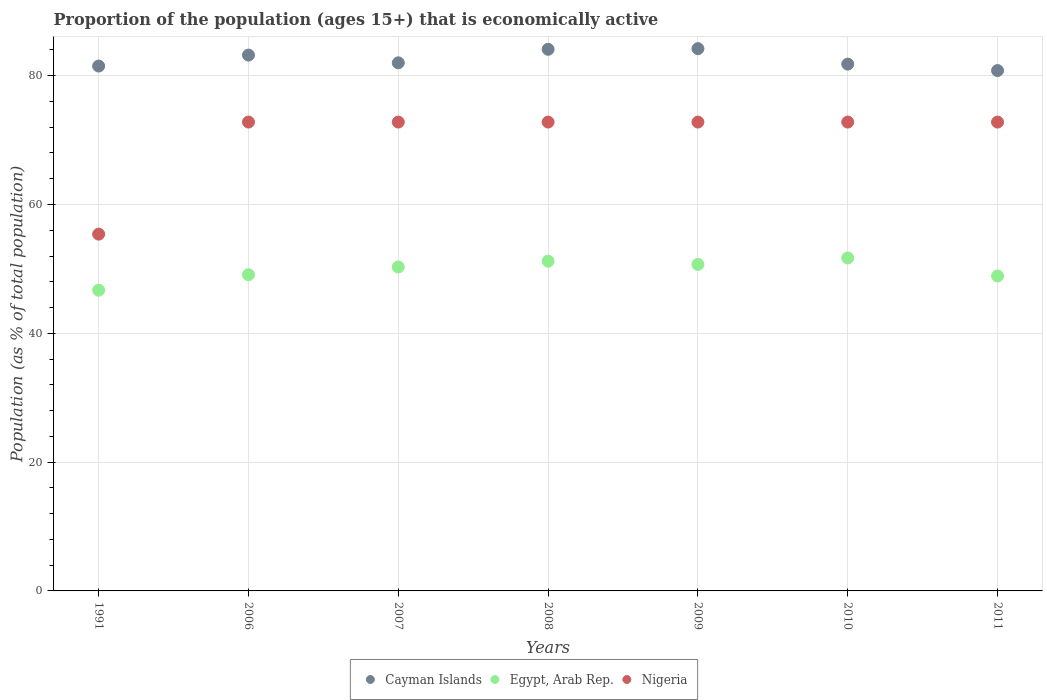Is the number of dotlines equal to the number of legend labels?
Make the answer very short. Yes. What is the proportion of the population that is economically active in Nigeria in 2011?
Ensure brevity in your answer.  72.8. Across all years, what is the maximum proportion of the population that is economically active in Nigeria?
Your response must be concise. 72.8. Across all years, what is the minimum proportion of the population that is economically active in Egypt, Arab Rep.?
Offer a very short reply. 46.7. In which year was the proportion of the population that is economically active in Egypt, Arab Rep. minimum?
Your answer should be very brief. 1991. What is the total proportion of the population that is economically active in Cayman Islands in the graph?
Provide a succinct answer. 577.6. What is the difference between the proportion of the population that is economically active in Cayman Islands in 1991 and that in 2009?
Offer a terse response. -2.7. What is the difference between the proportion of the population that is economically active in Nigeria in 1991 and the proportion of the population that is economically active in Egypt, Arab Rep. in 2007?
Keep it short and to the point. 5.1. What is the average proportion of the population that is economically active in Nigeria per year?
Provide a short and direct response. 70.31. In the year 2009, what is the difference between the proportion of the population that is economically active in Cayman Islands and proportion of the population that is economically active in Nigeria?
Offer a very short reply. 11.4. In how many years, is the proportion of the population that is economically active in Cayman Islands greater than 76 %?
Offer a very short reply. 7. What is the ratio of the proportion of the population that is economically active in Cayman Islands in 2009 to that in 2011?
Offer a terse response. 1.04. Is the difference between the proportion of the population that is economically active in Cayman Islands in 2008 and 2009 greater than the difference between the proportion of the population that is economically active in Nigeria in 2008 and 2009?
Your answer should be compact. No. What is the difference between the highest and the lowest proportion of the population that is economically active in Nigeria?
Offer a very short reply. 17.4. Is the proportion of the population that is economically active in Egypt, Arab Rep. strictly less than the proportion of the population that is economically active in Cayman Islands over the years?
Ensure brevity in your answer.  Yes. How many years are there in the graph?
Offer a terse response. 7. Does the graph contain any zero values?
Offer a very short reply. No. Does the graph contain grids?
Give a very brief answer. Yes. How many legend labels are there?
Ensure brevity in your answer.  3. How are the legend labels stacked?
Offer a very short reply. Horizontal. What is the title of the graph?
Your answer should be compact. Proportion of the population (ages 15+) that is economically active. Does "Macedonia" appear as one of the legend labels in the graph?
Your response must be concise. No. What is the label or title of the X-axis?
Make the answer very short. Years. What is the label or title of the Y-axis?
Give a very brief answer. Population (as % of total population). What is the Population (as % of total population) in Cayman Islands in 1991?
Your answer should be very brief. 81.5. What is the Population (as % of total population) in Egypt, Arab Rep. in 1991?
Your answer should be very brief. 46.7. What is the Population (as % of total population) in Nigeria in 1991?
Offer a terse response. 55.4. What is the Population (as % of total population) in Cayman Islands in 2006?
Offer a very short reply. 83.2. What is the Population (as % of total population) of Egypt, Arab Rep. in 2006?
Offer a terse response. 49.1. What is the Population (as % of total population) of Nigeria in 2006?
Offer a very short reply. 72.8. What is the Population (as % of total population) of Cayman Islands in 2007?
Give a very brief answer. 82. What is the Population (as % of total population) of Egypt, Arab Rep. in 2007?
Offer a terse response. 50.3. What is the Population (as % of total population) of Nigeria in 2007?
Keep it short and to the point. 72.8. What is the Population (as % of total population) in Cayman Islands in 2008?
Offer a terse response. 84.1. What is the Population (as % of total population) of Egypt, Arab Rep. in 2008?
Offer a terse response. 51.2. What is the Population (as % of total population) of Nigeria in 2008?
Ensure brevity in your answer.  72.8. What is the Population (as % of total population) of Cayman Islands in 2009?
Offer a very short reply. 84.2. What is the Population (as % of total population) in Egypt, Arab Rep. in 2009?
Offer a terse response. 50.7. What is the Population (as % of total population) in Nigeria in 2009?
Offer a very short reply. 72.8. What is the Population (as % of total population) in Cayman Islands in 2010?
Your response must be concise. 81.8. What is the Population (as % of total population) of Egypt, Arab Rep. in 2010?
Your answer should be compact. 51.7. What is the Population (as % of total population) of Nigeria in 2010?
Offer a very short reply. 72.8. What is the Population (as % of total population) in Cayman Islands in 2011?
Provide a succinct answer. 80.8. What is the Population (as % of total population) of Egypt, Arab Rep. in 2011?
Offer a terse response. 48.9. What is the Population (as % of total population) of Nigeria in 2011?
Your answer should be very brief. 72.8. Across all years, what is the maximum Population (as % of total population) in Cayman Islands?
Make the answer very short. 84.2. Across all years, what is the maximum Population (as % of total population) in Egypt, Arab Rep.?
Ensure brevity in your answer.  51.7. Across all years, what is the maximum Population (as % of total population) of Nigeria?
Provide a short and direct response. 72.8. Across all years, what is the minimum Population (as % of total population) in Cayman Islands?
Ensure brevity in your answer.  80.8. Across all years, what is the minimum Population (as % of total population) of Egypt, Arab Rep.?
Make the answer very short. 46.7. Across all years, what is the minimum Population (as % of total population) in Nigeria?
Your answer should be compact. 55.4. What is the total Population (as % of total population) of Cayman Islands in the graph?
Give a very brief answer. 577.6. What is the total Population (as % of total population) in Egypt, Arab Rep. in the graph?
Give a very brief answer. 348.6. What is the total Population (as % of total population) in Nigeria in the graph?
Provide a succinct answer. 492.2. What is the difference between the Population (as % of total population) in Nigeria in 1991 and that in 2006?
Offer a very short reply. -17.4. What is the difference between the Population (as % of total population) in Cayman Islands in 1991 and that in 2007?
Offer a very short reply. -0.5. What is the difference between the Population (as % of total population) in Egypt, Arab Rep. in 1991 and that in 2007?
Your answer should be very brief. -3.6. What is the difference between the Population (as % of total population) in Nigeria in 1991 and that in 2007?
Make the answer very short. -17.4. What is the difference between the Population (as % of total population) in Cayman Islands in 1991 and that in 2008?
Make the answer very short. -2.6. What is the difference between the Population (as % of total population) in Egypt, Arab Rep. in 1991 and that in 2008?
Give a very brief answer. -4.5. What is the difference between the Population (as % of total population) in Nigeria in 1991 and that in 2008?
Provide a succinct answer. -17.4. What is the difference between the Population (as % of total population) in Egypt, Arab Rep. in 1991 and that in 2009?
Keep it short and to the point. -4. What is the difference between the Population (as % of total population) in Nigeria in 1991 and that in 2009?
Your answer should be very brief. -17.4. What is the difference between the Population (as % of total population) in Egypt, Arab Rep. in 1991 and that in 2010?
Give a very brief answer. -5. What is the difference between the Population (as % of total population) in Nigeria in 1991 and that in 2010?
Keep it short and to the point. -17.4. What is the difference between the Population (as % of total population) in Cayman Islands in 1991 and that in 2011?
Provide a short and direct response. 0.7. What is the difference between the Population (as % of total population) in Egypt, Arab Rep. in 1991 and that in 2011?
Your answer should be very brief. -2.2. What is the difference between the Population (as % of total population) of Nigeria in 1991 and that in 2011?
Keep it short and to the point. -17.4. What is the difference between the Population (as % of total population) in Egypt, Arab Rep. in 2006 and that in 2007?
Ensure brevity in your answer.  -1.2. What is the difference between the Population (as % of total population) in Cayman Islands in 2006 and that in 2008?
Provide a short and direct response. -0.9. What is the difference between the Population (as % of total population) in Cayman Islands in 2006 and that in 2009?
Provide a succinct answer. -1. What is the difference between the Population (as % of total population) of Egypt, Arab Rep. in 2006 and that in 2009?
Your response must be concise. -1.6. What is the difference between the Population (as % of total population) of Nigeria in 2006 and that in 2009?
Provide a short and direct response. 0. What is the difference between the Population (as % of total population) of Cayman Islands in 2006 and that in 2010?
Offer a very short reply. 1.4. What is the difference between the Population (as % of total population) of Egypt, Arab Rep. in 2006 and that in 2010?
Provide a short and direct response. -2.6. What is the difference between the Population (as % of total population) of Nigeria in 2006 and that in 2010?
Offer a terse response. 0. What is the difference between the Population (as % of total population) of Cayman Islands in 2006 and that in 2011?
Your answer should be compact. 2.4. What is the difference between the Population (as % of total population) in Nigeria in 2006 and that in 2011?
Offer a terse response. 0. What is the difference between the Population (as % of total population) of Nigeria in 2007 and that in 2009?
Provide a short and direct response. 0. What is the difference between the Population (as % of total population) in Nigeria in 2007 and that in 2010?
Your answer should be compact. 0. What is the difference between the Population (as % of total population) of Cayman Islands in 2007 and that in 2011?
Give a very brief answer. 1.2. What is the difference between the Population (as % of total population) of Cayman Islands in 2008 and that in 2009?
Make the answer very short. -0.1. What is the difference between the Population (as % of total population) in Nigeria in 2008 and that in 2009?
Keep it short and to the point. 0. What is the difference between the Population (as % of total population) of Cayman Islands in 2008 and that in 2010?
Your response must be concise. 2.3. What is the difference between the Population (as % of total population) of Nigeria in 2008 and that in 2010?
Your answer should be very brief. 0. What is the difference between the Population (as % of total population) in Cayman Islands in 2008 and that in 2011?
Keep it short and to the point. 3.3. What is the difference between the Population (as % of total population) in Egypt, Arab Rep. in 2008 and that in 2011?
Your response must be concise. 2.3. What is the difference between the Population (as % of total population) in Cayman Islands in 2009 and that in 2010?
Provide a short and direct response. 2.4. What is the difference between the Population (as % of total population) in Nigeria in 2009 and that in 2010?
Offer a very short reply. 0. What is the difference between the Population (as % of total population) in Cayman Islands in 2009 and that in 2011?
Your answer should be compact. 3.4. What is the difference between the Population (as % of total population) in Egypt, Arab Rep. in 2009 and that in 2011?
Offer a very short reply. 1.8. What is the difference between the Population (as % of total population) in Cayman Islands in 2010 and that in 2011?
Make the answer very short. 1. What is the difference between the Population (as % of total population) of Egypt, Arab Rep. in 2010 and that in 2011?
Make the answer very short. 2.8. What is the difference between the Population (as % of total population) of Nigeria in 2010 and that in 2011?
Keep it short and to the point. 0. What is the difference between the Population (as % of total population) of Cayman Islands in 1991 and the Population (as % of total population) of Egypt, Arab Rep. in 2006?
Your response must be concise. 32.4. What is the difference between the Population (as % of total population) in Egypt, Arab Rep. in 1991 and the Population (as % of total population) in Nigeria in 2006?
Give a very brief answer. -26.1. What is the difference between the Population (as % of total population) in Cayman Islands in 1991 and the Population (as % of total population) in Egypt, Arab Rep. in 2007?
Your answer should be very brief. 31.2. What is the difference between the Population (as % of total population) in Egypt, Arab Rep. in 1991 and the Population (as % of total population) in Nigeria in 2007?
Ensure brevity in your answer.  -26.1. What is the difference between the Population (as % of total population) in Cayman Islands in 1991 and the Population (as % of total population) in Egypt, Arab Rep. in 2008?
Make the answer very short. 30.3. What is the difference between the Population (as % of total population) of Egypt, Arab Rep. in 1991 and the Population (as % of total population) of Nigeria in 2008?
Your response must be concise. -26.1. What is the difference between the Population (as % of total population) in Cayman Islands in 1991 and the Population (as % of total population) in Egypt, Arab Rep. in 2009?
Provide a short and direct response. 30.8. What is the difference between the Population (as % of total population) of Cayman Islands in 1991 and the Population (as % of total population) of Nigeria in 2009?
Provide a short and direct response. 8.7. What is the difference between the Population (as % of total population) of Egypt, Arab Rep. in 1991 and the Population (as % of total population) of Nigeria in 2009?
Provide a short and direct response. -26.1. What is the difference between the Population (as % of total population) of Cayman Islands in 1991 and the Population (as % of total population) of Egypt, Arab Rep. in 2010?
Your answer should be compact. 29.8. What is the difference between the Population (as % of total population) of Egypt, Arab Rep. in 1991 and the Population (as % of total population) of Nigeria in 2010?
Offer a very short reply. -26.1. What is the difference between the Population (as % of total population) in Cayman Islands in 1991 and the Population (as % of total population) in Egypt, Arab Rep. in 2011?
Provide a succinct answer. 32.6. What is the difference between the Population (as % of total population) of Cayman Islands in 1991 and the Population (as % of total population) of Nigeria in 2011?
Your answer should be very brief. 8.7. What is the difference between the Population (as % of total population) of Egypt, Arab Rep. in 1991 and the Population (as % of total population) of Nigeria in 2011?
Offer a very short reply. -26.1. What is the difference between the Population (as % of total population) in Cayman Islands in 2006 and the Population (as % of total population) in Egypt, Arab Rep. in 2007?
Give a very brief answer. 32.9. What is the difference between the Population (as % of total population) in Egypt, Arab Rep. in 2006 and the Population (as % of total population) in Nigeria in 2007?
Offer a terse response. -23.7. What is the difference between the Population (as % of total population) in Cayman Islands in 2006 and the Population (as % of total population) in Nigeria in 2008?
Your response must be concise. 10.4. What is the difference between the Population (as % of total population) of Egypt, Arab Rep. in 2006 and the Population (as % of total population) of Nigeria in 2008?
Keep it short and to the point. -23.7. What is the difference between the Population (as % of total population) of Cayman Islands in 2006 and the Population (as % of total population) of Egypt, Arab Rep. in 2009?
Your answer should be compact. 32.5. What is the difference between the Population (as % of total population) in Egypt, Arab Rep. in 2006 and the Population (as % of total population) in Nigeria in 2009?
Your answer should be very brief. -23.7. What is the difference between the Population (as % of total population) in Cayman Islands in 2006 and the Population (as % of total population) in Egypt, Arab Rep. in 2010?
Keep it short and to the point. 31.5. What is the difference between the Population (as % of total population) in Egypt, Arab Rep. in 2006 and the Population (as % of total population) in Nigeria in 2010?
Make the answer very short. -23.7. What is the difference between the Population (as % of total population) in Cayman Islands in 2006 and the Population (as % of total population) in Egypt, Arab Rep. in 2011?
Provide a succinct answer. 34.3. What is the difference between the Population (as % of total population) in Egypt, Arab Rep. in 2006 and the Population (as % of total population) in Nigeria in 2011?
Give a very brief answer. -23.7. What is the difference between the Population (as % of total population) in Cayman Islands in 2007 and the Population (as % of total population) in Egypt, Arab Rep. in 2008?
Make the answer very short. 30.8. What is the difference between the Population (as % of total population) of Cayman Islands in 2007 and the Population (as % of total population) of Nigeria in 2008?
Your answer should be compact. 9.2. What is the difference between the Population (as % of total population) in Egypt, Arab Rep. in 2007 and the Population (as % of total population) in Nigeria in 2008?
Ensure brevity in your answer.  -22.5. What is the difference between the Population (as % of total population) of Cayman Islands in 2007 and the Population (as % of total population) of Egypt, Arab Rep. in 2009?
Your answer should be compact. 31.3. What is the difference between the Population (as % of total population) in Cayman Islands in 2007 and the Population (as % of total population) in Nigeria in 2009?
Offer a terse response. 9.2. What is the difference between the Population (as % of total population) of Egypt, Arab Rep. in 2007 and the Population (as % of total population) of Nigeria in 2009?
Your answer should be compact. -22.5. What is the difference between the Population (as % of total population) of Cayman Islands in 2007 and the Population (as % of total population) of Egypt, Arab Rep. in 2010?
Make the answer very short. 30.3. What is the difference between the Population (as % of total population) in Cayman Islands in 2007 and the Population (as % of total population) in Nigeria in 2010?
Offer a very short reply. 9.2. What is the difference between the Population (as % of total population) of Egypt, Arab Rep. in 2007 and the Population (as % of total population) of Nigeria in 2010?
Provide a short and direct response. -22.5. What is the difference between the Population (as % of total population) in Cayman Islands in 2007 and the Population (as % of total population) in Egypt, Arab Rep. in 2011?
Provide a short and direct response. 33.1. What is the difference between the Population (as % of total population) of Egypt, Arab Rep. in 2007 and the Population (as % of total population) of Nigeria in 2011?
Offer a terse response. -22.5. What is the difference between the Population (as % of total population) in Cayman Islands in 2008 and the Population (as % of total population) in Egypt, Arab Rep. in 2009?
Ensure brevity in your answer.  33.4. What is the difference between the Population (as % of total population) in Egypt, Arab Rep. in 2008 and the Population (as % of total population) in Nigeria in 2009?
Provide a succinct answer. -21.6. What is the difference between the Population (as % of total population) of Cayman Islands in 2008 and the Population (as % of total population) of Egypt, Arab Rep. in 2010?
Provide a succinct answer. 32.4. What is the difference between the Population (as % of total population) in Egypt, Arab Rep. in 2008 and the Population (as % of total population) in Nigeria in 2010?
Provide a succinct answer. -21.6. What is the difference between the Population (as % of total population) of Cayman Islands in 2008 and the Population (as % of total population) of Egypt, Arab Rep. in 2011?
Provide a short and direct response. 35.2. What is the difference between the Population (as % of total population) of Cayman Islands in 2008 and the Population (as % of total population) of Nigeria in 2011?
Your answer should be very brief. 11.3. What is the difference between the Population (as % of total population) of Egypt, Arab Rep. in 2008 and the Population (as % of total population) of Nigeria in 2011?
Your response must be concise. -21.6. What is the difference between the Population (as % of total population) in Cayman Islands in 2009 and the Population (as % of total population) in Egypt, Arab Rep. in 2010?
Offer a terse response. 32.5. What is the difference between the Population (as % of total population) of Cayman Islands in 2009 and the Population (as % of total population) of Nigeria in 2010?
Your answer should be compact. 11.4. What is the difference between the Population (as % of total population) in Egypt, Arab Rep. in 2009 and the Population (as % of total population) in Nigeria in 2010?
Your response must be concise. -22.1. What is the difference between the Population (as % of total population) in Cayman Islands in 2009 and the Population (as % of total population) in Egypt, Arab Rep. in 2011?
Your answer should be very brief. 35.3. What is the difference between the Population (as % of total population) in Egypt, Arab Rep. in 2009 and the Population (as % of total population) in Nigeria in 2011?
Your answer should be very brief. -22.1. What is the difference between the Population (as % of total population) in Cayman Islands in 2010 and the Population (as % of total population) in Egypt, Arab Rep. in 2011?
Give a very brief answer. 32.9. What is the difference between the Population (as % of total population) in Egypt, Arab Rep. in 2010 and the Population (as % of total population) in Nigeria in 2011?
Offer a terse response. -21.1. What is the average Population (as % of total population) of Cayman Islands per year?
Provide a succinct answer. 82.51. What is the average Population (as % of total population) in Egypt, Arab Rep. per year?
Provide a short and direct response. 49.8. What is the average Population (as % of total population) in Nigeria per year?
Your answer should be compact. 70.31. In the year 1991, what is the difference between the Population (as % of total population) of Cayman Islands and Population (as % of total population) of Egypt, Arab Rep.?
Your answer should be very brief. 34.8. In the year 1991, what is the difference between the Population (as % of total population) in Cayman Islands and Population (as % of total population) in Nigeria?
Make the answer very short. 26.1. In the year 2006, what is the difference between the Population (as % of total population) in Cayman Islands and Population (as % of total population) in Egypt, Arab Rep.?
Provide a succinct answer. 34.1. In the year 2006, what is the difference between the Population (as % of total population) in Egypt, Arab Rep. and Population (as % of total population) in Nigeria?
Provide a succinct answer. -23.7. In the year 2007, what is the difference between the Population (as % of total population) of Cayman Islands and Population (as % of total population) of Egypt, Arab Rep.?
Keep it short and to the point. 31.7. In the year 2007, what is the difference between the Population (as % of total population) in Egypt, Arab Rep. and Population (as % of total population) in Nigeria?
Your answer should be very brief. -22.5. In the year 2008, what is the difference between the Population (as % of total population) of Cayman Islands and Population (as % of total population) of Egypt, Arab Rep.?
Your answer should be very brief. 32.9. In the year 2008, what is the difference between the Population (as % of total population) of Egypt, Arab Rep. and Population (as % of total population) of Nigeria?
Keep it short and to the point. -21.6. In the year 2009, what is the difference between the Population (as % of total population) of Cayman Islands and Population (as % of total population) of Egypt, Arab Rep.?
Your response must be concise. 33.5. In the year 2009, what is the difference between the Population (as % of total population) of Egypt, Arab Rep. and Population (as % of total population) of Nigeria?
Make the answer very short. -22.1. In the year 2010, what is the difference between the Population (as % of total population) in Cayman Islands and Population (as % of total population) in Egypt, Arab Rep.?
Your answer should be compact. 30.1. In the year 2010, what is the difference between the Population (as % of total population) of Egypt, Arab Rep. and Population (as % of total population) of Nigeria?
Ensure brevity in your answer.  -21.1. In the year 2011, what is the difference between the Population (as % of total population) in Cayman Islands and Population (as % of total population) in Egypt, Arab Rep.?
Give a very brief answer. 31.9. In the year 2011, what is the difference between the Population (as % of total population) in Cayman Islands and Population (as % of total population) in Nigeria?
Give a very brief answer. 8. In the year 2011, what is the difference between the Population (as % of total population) in Egypt, Arab Rep. and Population (as % of total population) in Nigeria?
Offer a terse response. -23.9. What is the ratio of the Population (as % of total population) in Cayman Islands in 1991 to that in 2006?
Your answer should be compact. 0.98. What is the ratio of the Population (as % of total population) of Egypt, Arab Rep. in 1991 to that in 2006?
Ensure brevity in your answer.  0.95. What is the ratio of the Population (as % of total population) of Nigeria in 1991 to that in 2006?
Ensure brevity in your answer.  0.76. What is the ratio of the Population (as % of total population) of Cayman Islands in 1991 to that in 2007?
Keep it short and to the point. 0.99. What is the ratio of the Population (as % of total population) of Egypt, Arab Rep. in 1991 to that in 2007?
Make the answer very short. 0.93. What is the ratio of the Population (as % of total population) of Nigeria in 1991 to that in 2007?
Ensure brevity in your answer.  0.76. What is the ratio of the Population (as % of total population) in Cayman Islands in 1991 to that in 2008?
Your response must be concise. 0.97. What is the ratio of the Population (as % of total population) of Egypt, Arab Rep. in 1991 to that in 2008?
Your answer should be compact. 0.91. What is the ratio of the Population (as % of total population) of Nigeria in 1991 to that in 2008?
Your answer should be very brief. 0.76. What is the ratio of the Population (as % of total population) in Cayman Islands in 1991 to that in 2009?
Give a very brief answer. 0.97. What is the ratio of the Population (as % of total population) of Egypt, Arab Rep. in 1991 to that in 2009?
Ensure brevity in your answer.  0.92. What is the ratio of the Population (as % of total population) in Nigeria in 1991 to that in 2009?
Ensure brevity in your answer.  0.76. What is the ratio of the Population (as % of total population) in Egypt, Arab Rep. in 1991 to that in 2010?
Your answer should be compact. 0.9. What is the ratio of the Population (as % of total population) of Nigeria in 1991 to that in 2010?
Ensure brevity in your answer.  0.76. What is the ratio of the Population (as % of total population) of Cayman Islands in 1991 to that in 2011?
Ensure brevity in your answer.  1.01. What is the ratio of the Population (as % of total population) in Egypt, Arab Rep. in 1991 to that in 2011?
Offer a terse response. 0.95. What is the ratio of the Population (as % of total population) in Nigeria in 1991 to that in 2011?
Provide a short and direct response. 0.76. What is the ratio of the Population (as % of total population) in Cayman Islands in 2006 to that in 2007?
Make the answer very short. 1.01. What is the ratio of the Population (as % of total population) of Egypt, Arab Rep. in 2006 to that in 2007?
Your answer should be compact. 0.98. What is the ratio of the Population (as % of total population) of Cayman Islands in 2006 to that in 2008?
Make the answer very short. 0.99. What is the ratio of the Population (as % of total population) in Egypt, Arab Rep. in 2006 to that in 2009?
Offer a terse response. 0.97. What is the ratio of the Population (as % of total population) of Nigeria in 2006 to that in 2009?
Your response must be concise. 1. What is the ratio of the Population (as % of total population) of Cayman Islands in 2006 to that in 2010?
Ensure brevity in your answer.  1.02. What is the ratio of the Population (as % of total population) of Egypt, Arab Rep. in 2006 to that in 2010?
Provide a succinct answer. 0.95. What is the ratio of the Population (as % of total population) in Nigeria in 2006 to that in 2010?
Keep it short and to the point. 1. What is the ratio of the Population (as % of total population) of Cayman Islands in 2006 to that in 2011?
Offer a very short reply. 1.03. What is the ratio of the Population (as % of total population) of Egypt, Arab Rep. in 2006 to that in 2011?
Ensure brevity in your answer.  1. What is the ratio of the Population (as % of total population) in Cayman Islands in 2007 to that in 2008?
Offer a terse response. 0.97. What is the ratio of the Population (as % of total population) of Egypt, Arab Rep. in 2007 to that in 2008?
Provide a succinct answer. 0.98. What is the ratio of the Population (as % of total population) of Nigeria in 2007 to that in 2008?
Make the answer very short. 1. What is the ratio of the Population (as % of total population) in Cayman Islands in 2007 to that in 2009?
Your answer should be very brief. 0.97. What is the ratio of the Population (as % of total population) in Egypt, Arab Rep. in 2007 to that in 2009?
Offer a very short reply. 0.99. What is the ratio of the Population (as % of total population) in Cayman Islands in 2007 to that in 2010?
Your answer should be very brief. 1. What is the ratio of the Population (as % of total population) in Egypt, Arab Rep. in 2007 to that in 2010?
Your response must be concise. 0.97. What is the ratio of the Population (as % of total population) in Nigeria in 2007 to that in 2010?
Ensure brevity in your answer.  1. What is the ratio of the Population (as % of total population) in Cayman Islands in 2007 to that in 2011?
Offer a terse response. 1.01. What is the ratio of the Population (as % of total population) in Egypt, Arab Rep. in 2007 to that in 2011?
Ensure brevity in your answer.  1.03. What is the ratio of the Population (as % of total population) in Cayman Islands in 2008 to that in 2009?
Your answer should be very brief. 1. What is the ratio of the Population (as % of total population) in Egypt, Arab Rep. in 2008 to that in 2009?
Give a very brief answer. 1.01. What is the ratio of the Population (as % of total population) of Nigeria in 2008 to that in 2009?
Your answer should be very brief. 1. What is the ratio of the Population (as % of total population) in Cayman Islands in 2008 to that in 2010?
Ensure brevity in your answer.  1.03. What is the ratio of the Population (as % of total population) in Egypt, Arab Rep. in 2008 to that in 2010?
Keep it short and to the point. 0.99. What is the ratio of the Population (as % of total population) in Cayman Islands in 2008 to that in 2011?
Make the answer very short. 1.04. What is the ratio of the Population (as % of total population) of Egypt, Arab Rep. in 2008 to that in 2011?
Keep it short and to the point. 1.05. What is the ratio of the Population (as % of total population) of Cayman Islands in 2009 to that in 2010?
Keep it short and to the point. 1.03. What is the ratio of the Population (as % of total population) in Egypt, Arab Rep. in 2009 to that in 2010?
Offer a terse response. 0.98. What is the ratio of the Population (as % of total population) in Cayman Islands in 2009 to that in 2011?
Give a very brief answer. 1.04. What is the ratio of the Population (as % of total population) in Egypt, Arab Rep. in 2009 to that in 2011?
Your response must be concise. 1.04. What is the ratio of the Population (as % of total population) in Nigeria in 2009 to that in 2011?
Your response must be concise. 1. What is the ratio of the Population (as % of total population) of Cayman Islands in 2010 to that in 2011?
Offer a very short reply. 1.01. What is the ratio of the Population (as % of total population) of Egypt, Arab Rep. in 2010 to that in 2011?
Keep it short and to the point. 1.06. What is the difference between the highest and the second highest Population (as % of total population) of Cayman Islands?
Make the answer very short. 0.1. What is the difference between the highest and the second highest Population (as % of total population) of Egypt, Arab Rep.?
Make the answer very short. 0.5. What is the difference between the highest and the second highest Population (as % of total population) of Nigeria?
Provide a short and direct response. 0. What is the difference between the highest and the lowest Population (as % of total population) of Nigeria?
Your answer should be very brief. 17.4. 